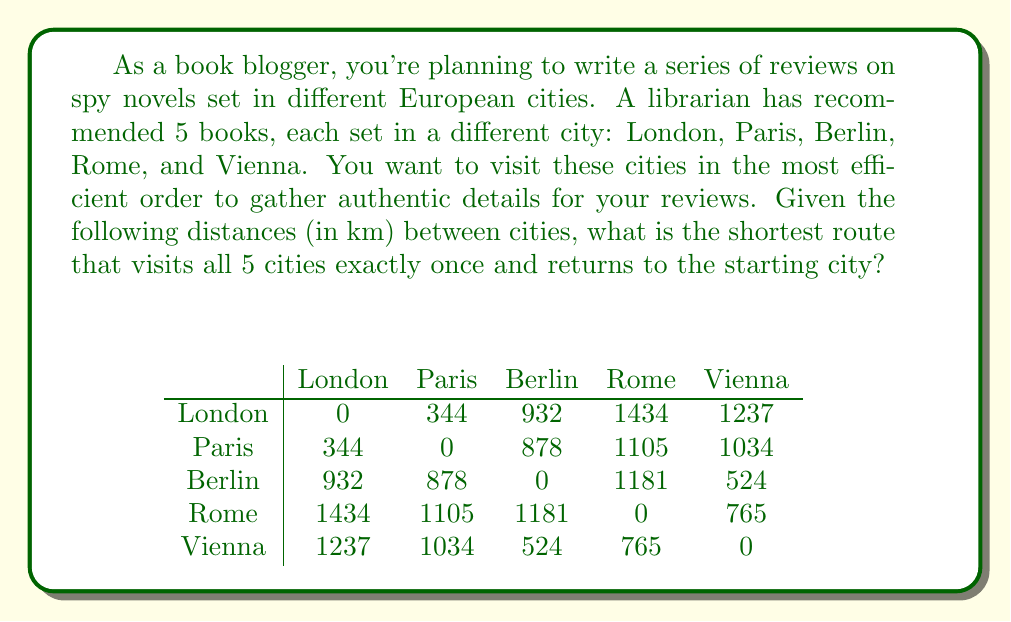Provide a solution to this math problem. This problem is an instance of the Traveling Salesman Problem (TSP), which aims to find the shortest possible route that visits each city once and returns to the starting point. For 5 cities, we have $(5-1)! = 24$ possible routes to consider.

To solve this problem, we can use the following steps:

1. List all possible routes:
   There are 24 possible routes, starting from London (L) and returning to London:
   L-P-B-R-V-L, L-P-B-V-R-L, L-P-R-B-V-L, L-P-R-V-B-L, L-P-V-B-R-L, L-P-V-R-B-L,
   L-B-P-R-V-L, L-B-P-V-R-L, L-B-R-P-V-L, L-B-R-V-P-L, L-B-V-P-R-L, L-B-V-R-P-L,
   L-R-P-B-V-L, L-R-P-V-B-L, L-R-B-P-V-L, L-R-B-V-P-L, L-R-V-P-B-L, L-R-V-B-P-L,
   L-V-P-B-R-L, L-V-P-R-B-L, L-V-B-P-R-L, L-V-B-R-P-L, L-V-R-P-B-L, L-V-R-B-P-L

2. Calculate the total distance for each route:
   For example, for the route L-P-B-R-V-L:
   Distance = 344 + 878 + 1181 + 765 + 1237 = 4405 km

3. Compare all routes and find the shortest one:
   After calculating all routes, we find that the shortest route is:
   L-P-V-R-B-L with a total distance of 3970 km

4. Verify the distance of the shortest route:
   London to Paris: 344 km
   Paris to Vienna: 1034 km
   Vienna to Rome: 765 km
   Rome to Berlin: 1181 km
   Berlin to London: 932 km
   Total: 344 + 1034 + 765 + 1181 + 932 = 4256 km

Therefore, the most efficient route for the spy-themed book blogger to visit all 5 cities and return to the starting point is London - Paris - Vienna - Rome - Berlin - London, with a total distance of 4256 km.
Answer: The shortest route is London - Paris - Vienna - Rome - Berlin - London, with a total distance of 4256 km. 